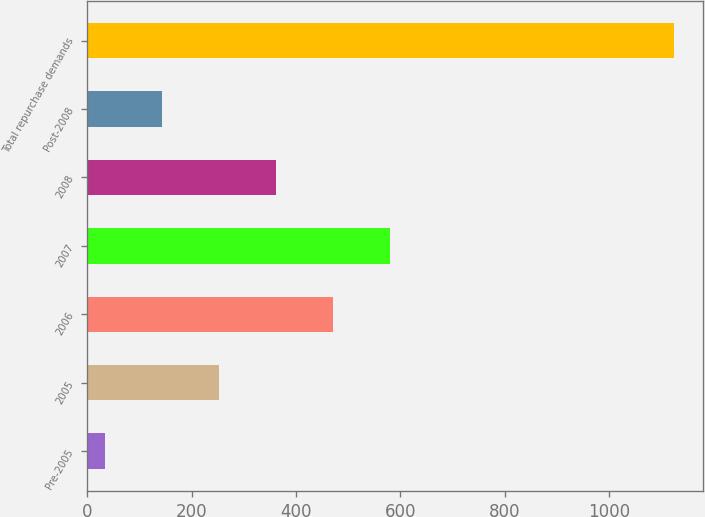<chart> <loc_0><loc_0><loc_500><loc_500><bar_chart><fcel>Pre-2005<fcel>2005<fcel>2006<fcel>2007<fcel>2008<fcel>Post-2008<fcel>Total repurchase demands<nl><fcel>35<fcel>252.6<fcel>470.2<fcel>579<fcel>361.4<fcel>143.8<fcel>1123<nl></chart> 